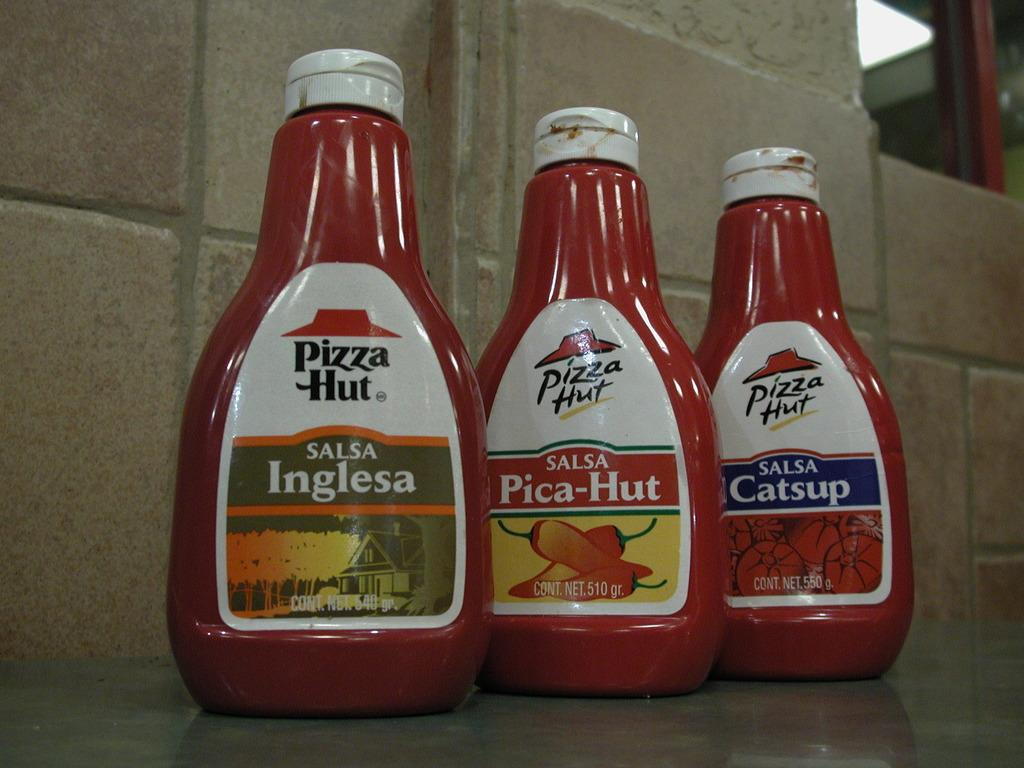<image>
Describe the image concisely. A row of three Pizza Hut branded salsa condiments. 